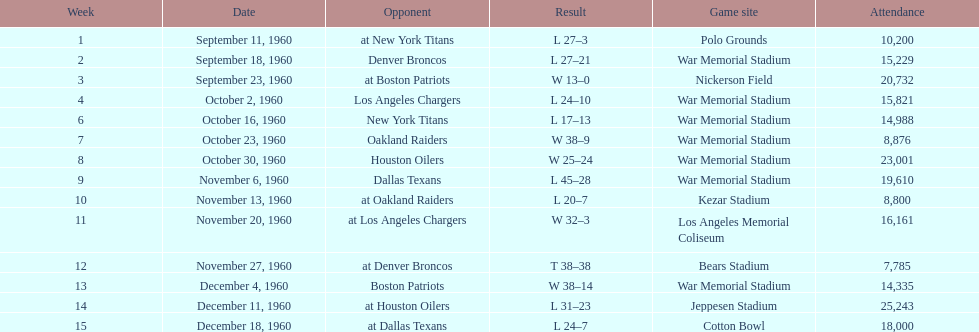What was the greatest point margin in a single game? 29. 